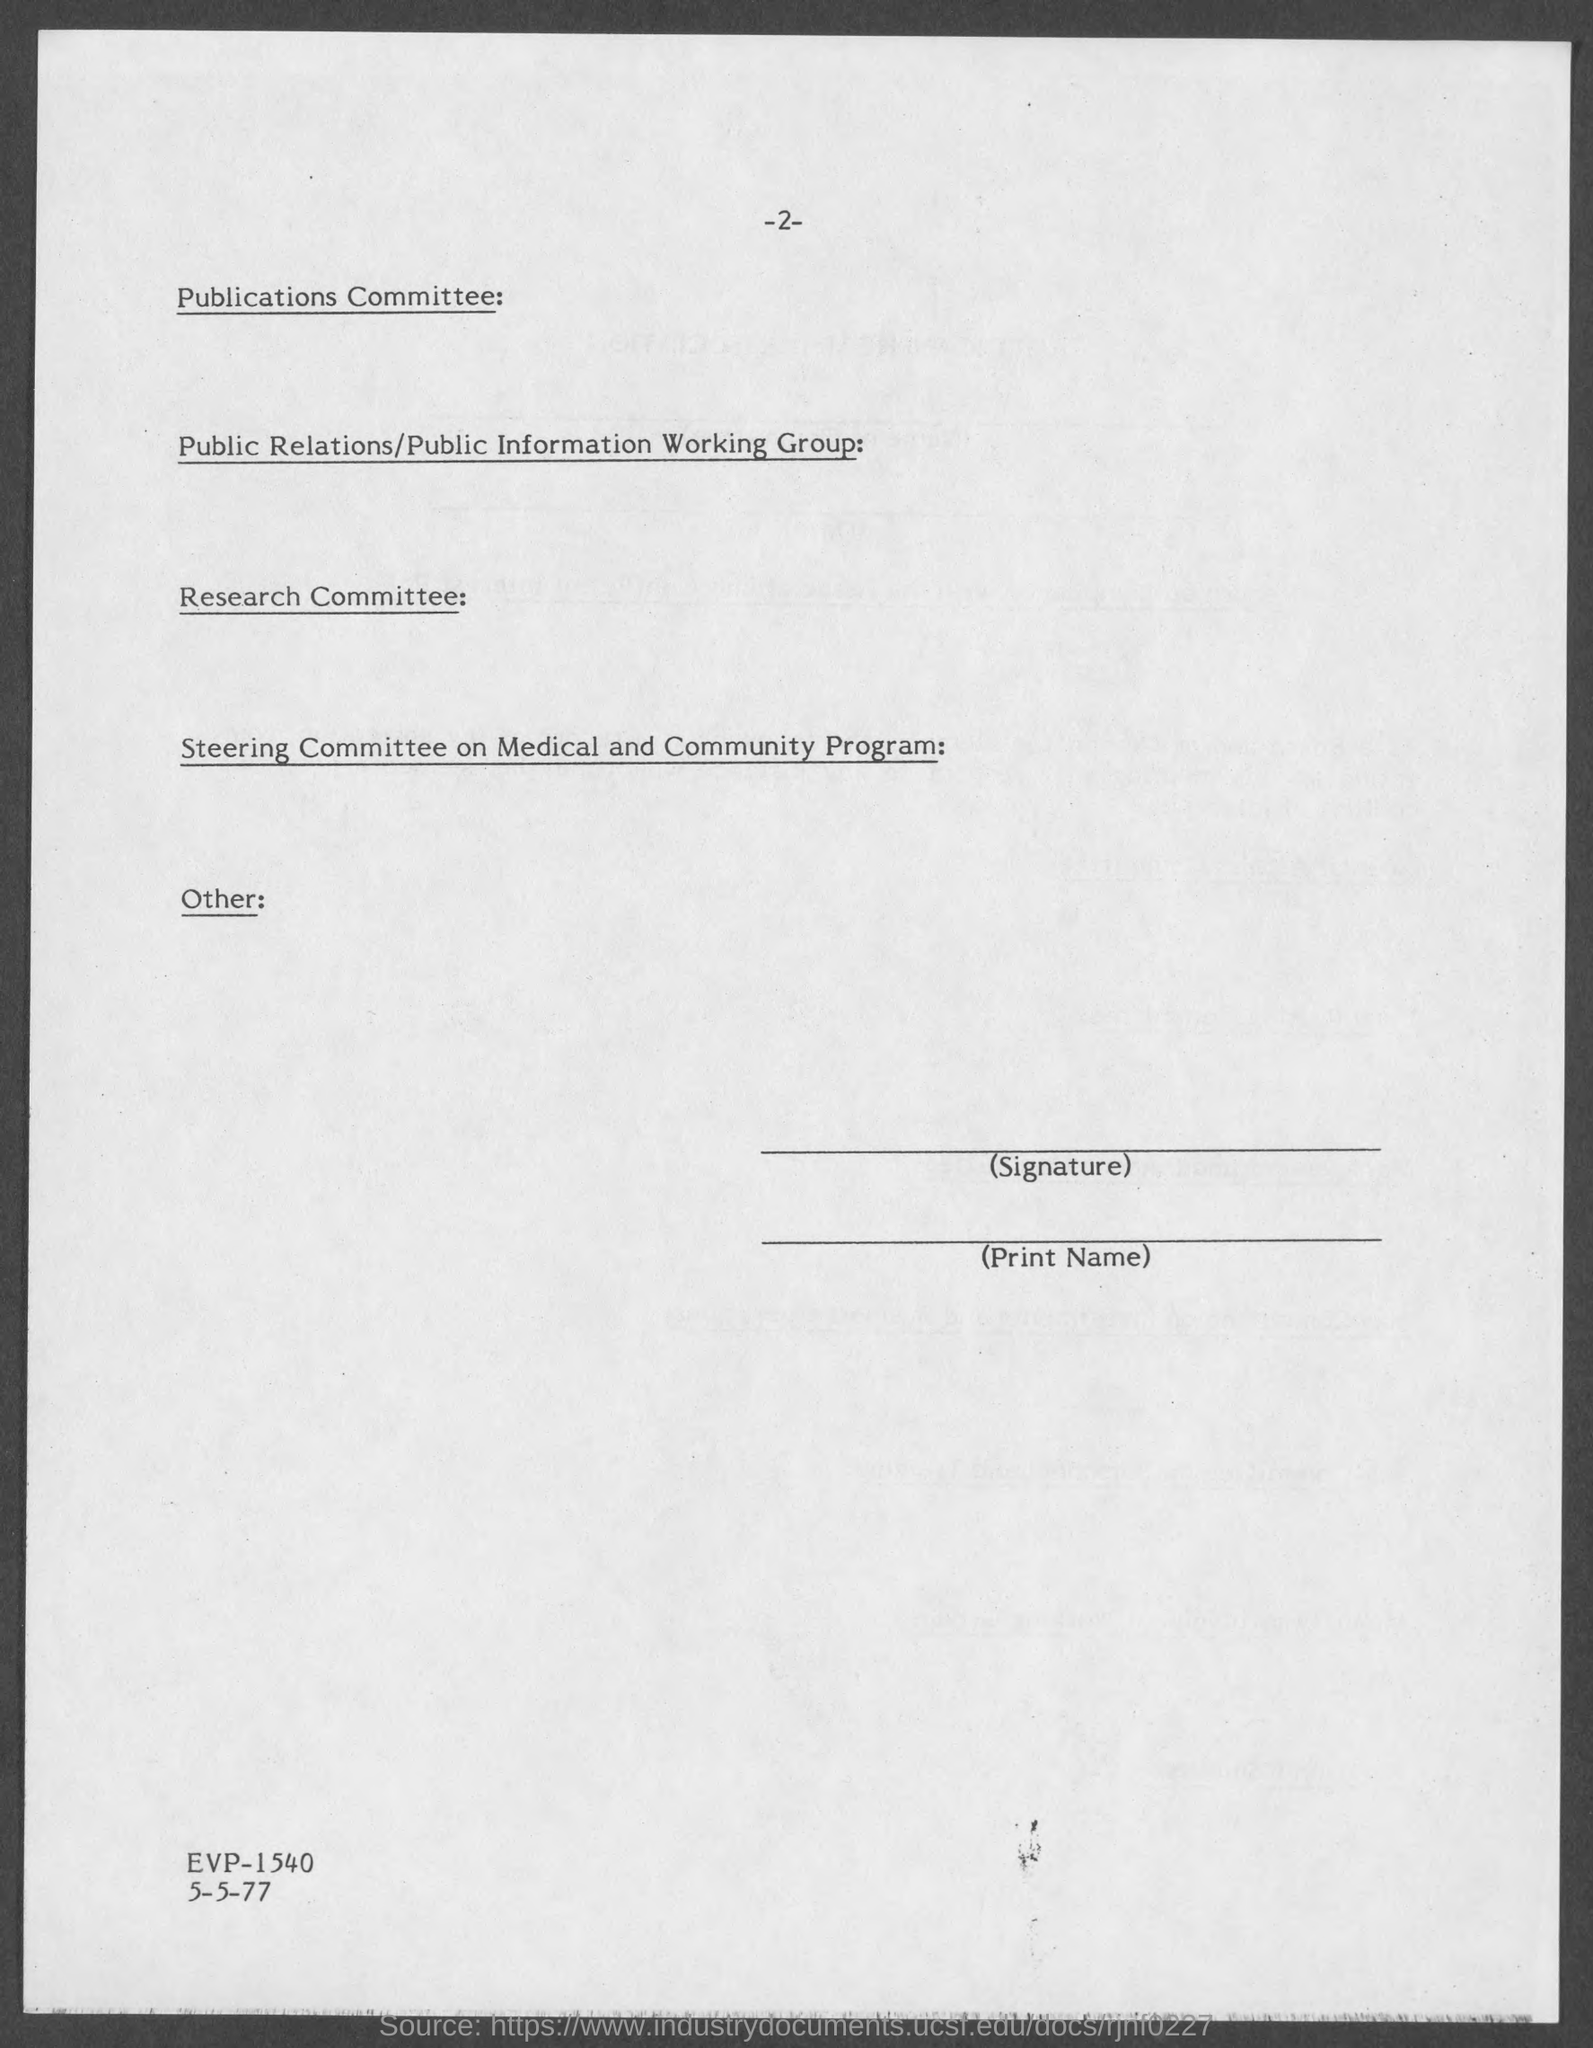Give some essential details in this illustration. The page number at the top of the page is -2-. 